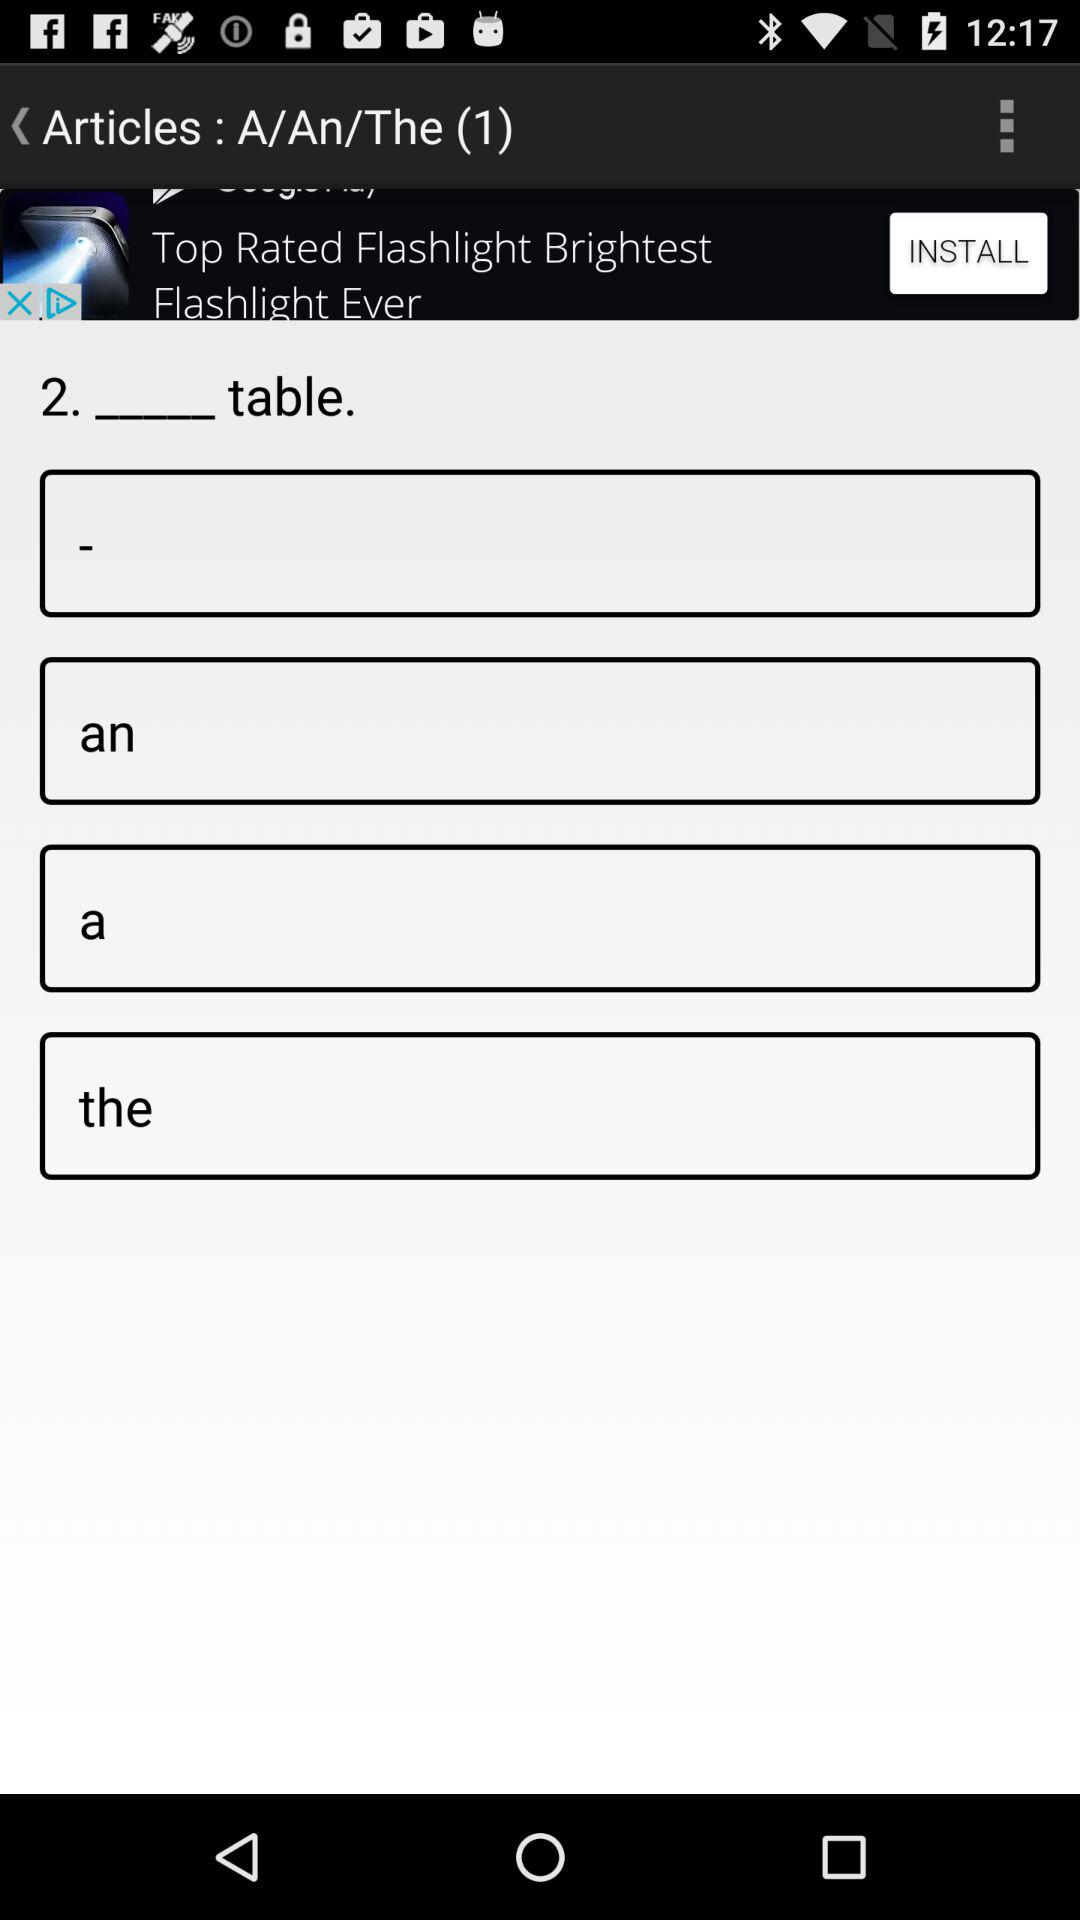How many of the text inputs have an article?
Answer the question using a single word or phrase. 3 